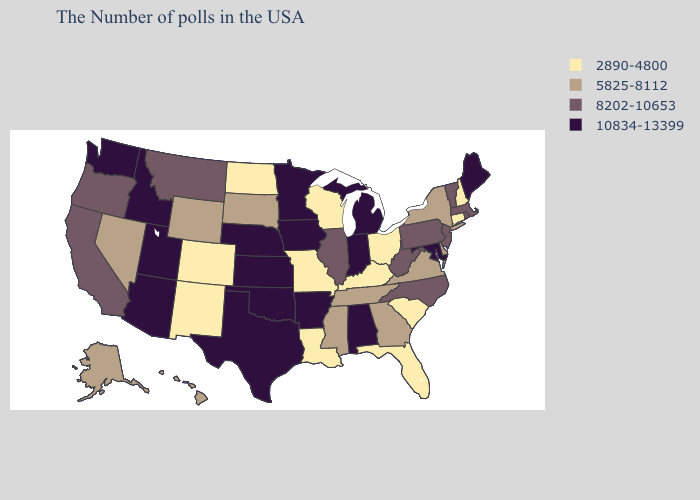Does Iowa have a higher value than Texas?
Concise answer only. No. Name the states that have a value in the range 10834-13399?
Quick response, please. Maine, Maryland, Michigan, Indiana, Alabama, Arkansas, Minnesota, Iowa, Kansas, Nebraska, Oklahoma, Texas, Utah, Arizona, Idaho, Washington. Among the states that border Colorado , which have the highest value?
Short answer required. Kansas, Nebraska, Oklahoma, Utah, Arizona. What is the value of Oklahoma?
Quick response, please. 10834-13399. Does Kentucky have the lowest value in the USA?
Answer briefly. Yes. Among the states that border Virginia , which have the highest value?
Give a very brief answer. Maryland. What is the highest value in the USA?
Short answer required. 10834-13399. Does Rhode Island have a lower value than Maine?
Short answer required. Yes. What is the value of California?
Write a very short answer. 8202-10653. What is the value of New Hampshire?
Keep it brief. 2890-4800. Name the states that have a value in the range 8202-10653?
Be succinct. Massachusetts, Rhode Island, Vermont, New Jersey, Pennsylvania, North Carolina, West Virginia, Illinois, Montana, California, Oregon. Which states have the highest value in the USA?
Short answer required. Maine, Maryland, Michigan, Indiana, Alabama, Arkansas, Minnesota, Iowa, Kansas, Nebraska, Oklahoma, Texas, Utah, Arizona, Idaho, Washington. Does Maine have the lowest value in the Northeast?
Write a very short answer. No. What is the highest value in the USA?
Keep it brief. 10834-13399. What is the value of Colorado?
Quick response, please. 2890-4800. 